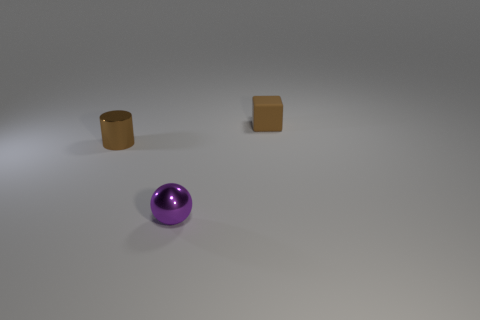Add 2 purple balls. How many objects exist? 5 Subtract all cylinders. How many objects are left? 2 Add 2 small cubes. How many small cubes exist? 3 Subtract 1 brown blocks. How many objects are left? 2 Subtract all big gray matte cylinders. Subtract all tiny shiny objects. How many objects are left? 1 Add 3 tiny rubber cubes. How many tiny rubber cubes are left? 4 